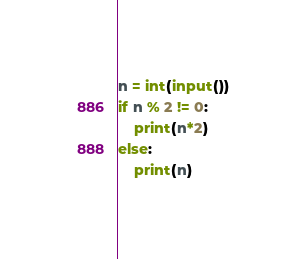Convert code to text. <code><loc_0><loc_0><loc_500><loc_500><_Python_>n = int(input())
if n % 2 != 0:
    print(n*2)
else:
    print(n)</code> 